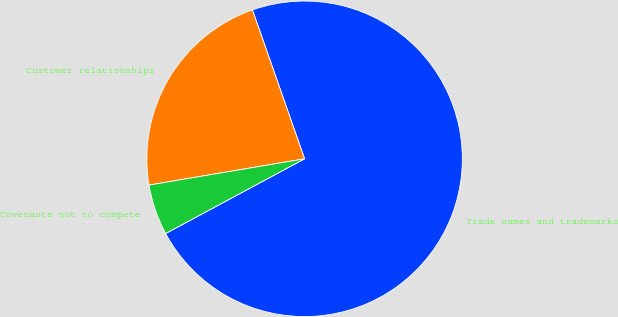Convert chart. <chart><loc_0><loc_0><loc_500><loc_500><pie_chart><fcel>Trade names and trademarks<fcel>Customer relationships<fcel>Covenants not to compete<nl><fcel>72.51%<fcel>22.3%<fcel>5.19%<nl></chart> 